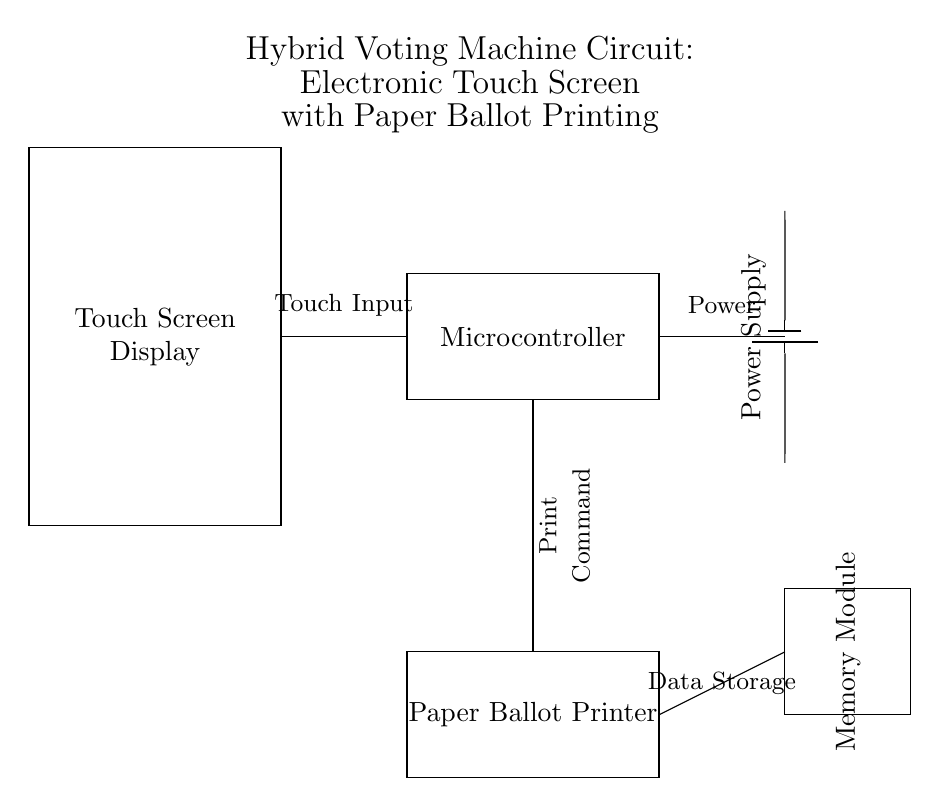What is the main function of the touch screen in this circuit? The touch screen serves as the user interface for voters to select their choices electronically. It provides the input functionality for the voting machine.
Answer: User interface What component is responsible for data storage? The memory module is used to store the data related to the votes and possibly the user interface information.
Answer: Memory module How does the microcontroller interact with the touch screen? The microcontroller processes the inputs received from the touch screen and generates appropriate outputs such as printing the ballot and storing data.
Answer: Processes inputs What is the role of the battery in this circuit? The battery acts as the power supply, providing the necessary electrical energy to operate all components of the voting machine.
Answer: Power supply Which component executes the command to print the paper ballot? The paper ballot printer receives the print command issued by the microcontroller when a vote is finalized.
Answer: Paper ballot printer What connection is made from the microcontroller to the memory module? The connection facilitates data transfer such as saving the selected votes to the memory module for later retrieval.
Answer: Data transfer 